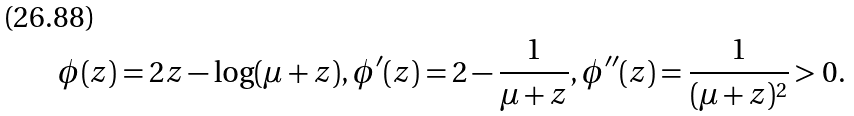<formula> <loc_0><loc_0><loc_500><loc_500>\phi ( z ) = 2 z - \log ( \mu + z ) , \phi ^ { \prime } ( z ) = 2 - \frac { 1 } { \mu + z } , \phi ^ { \prime \prime } ( z ) = \frac { 1 } { ( \mu + z ) ^ { 2 } } > 0 .</formula> 